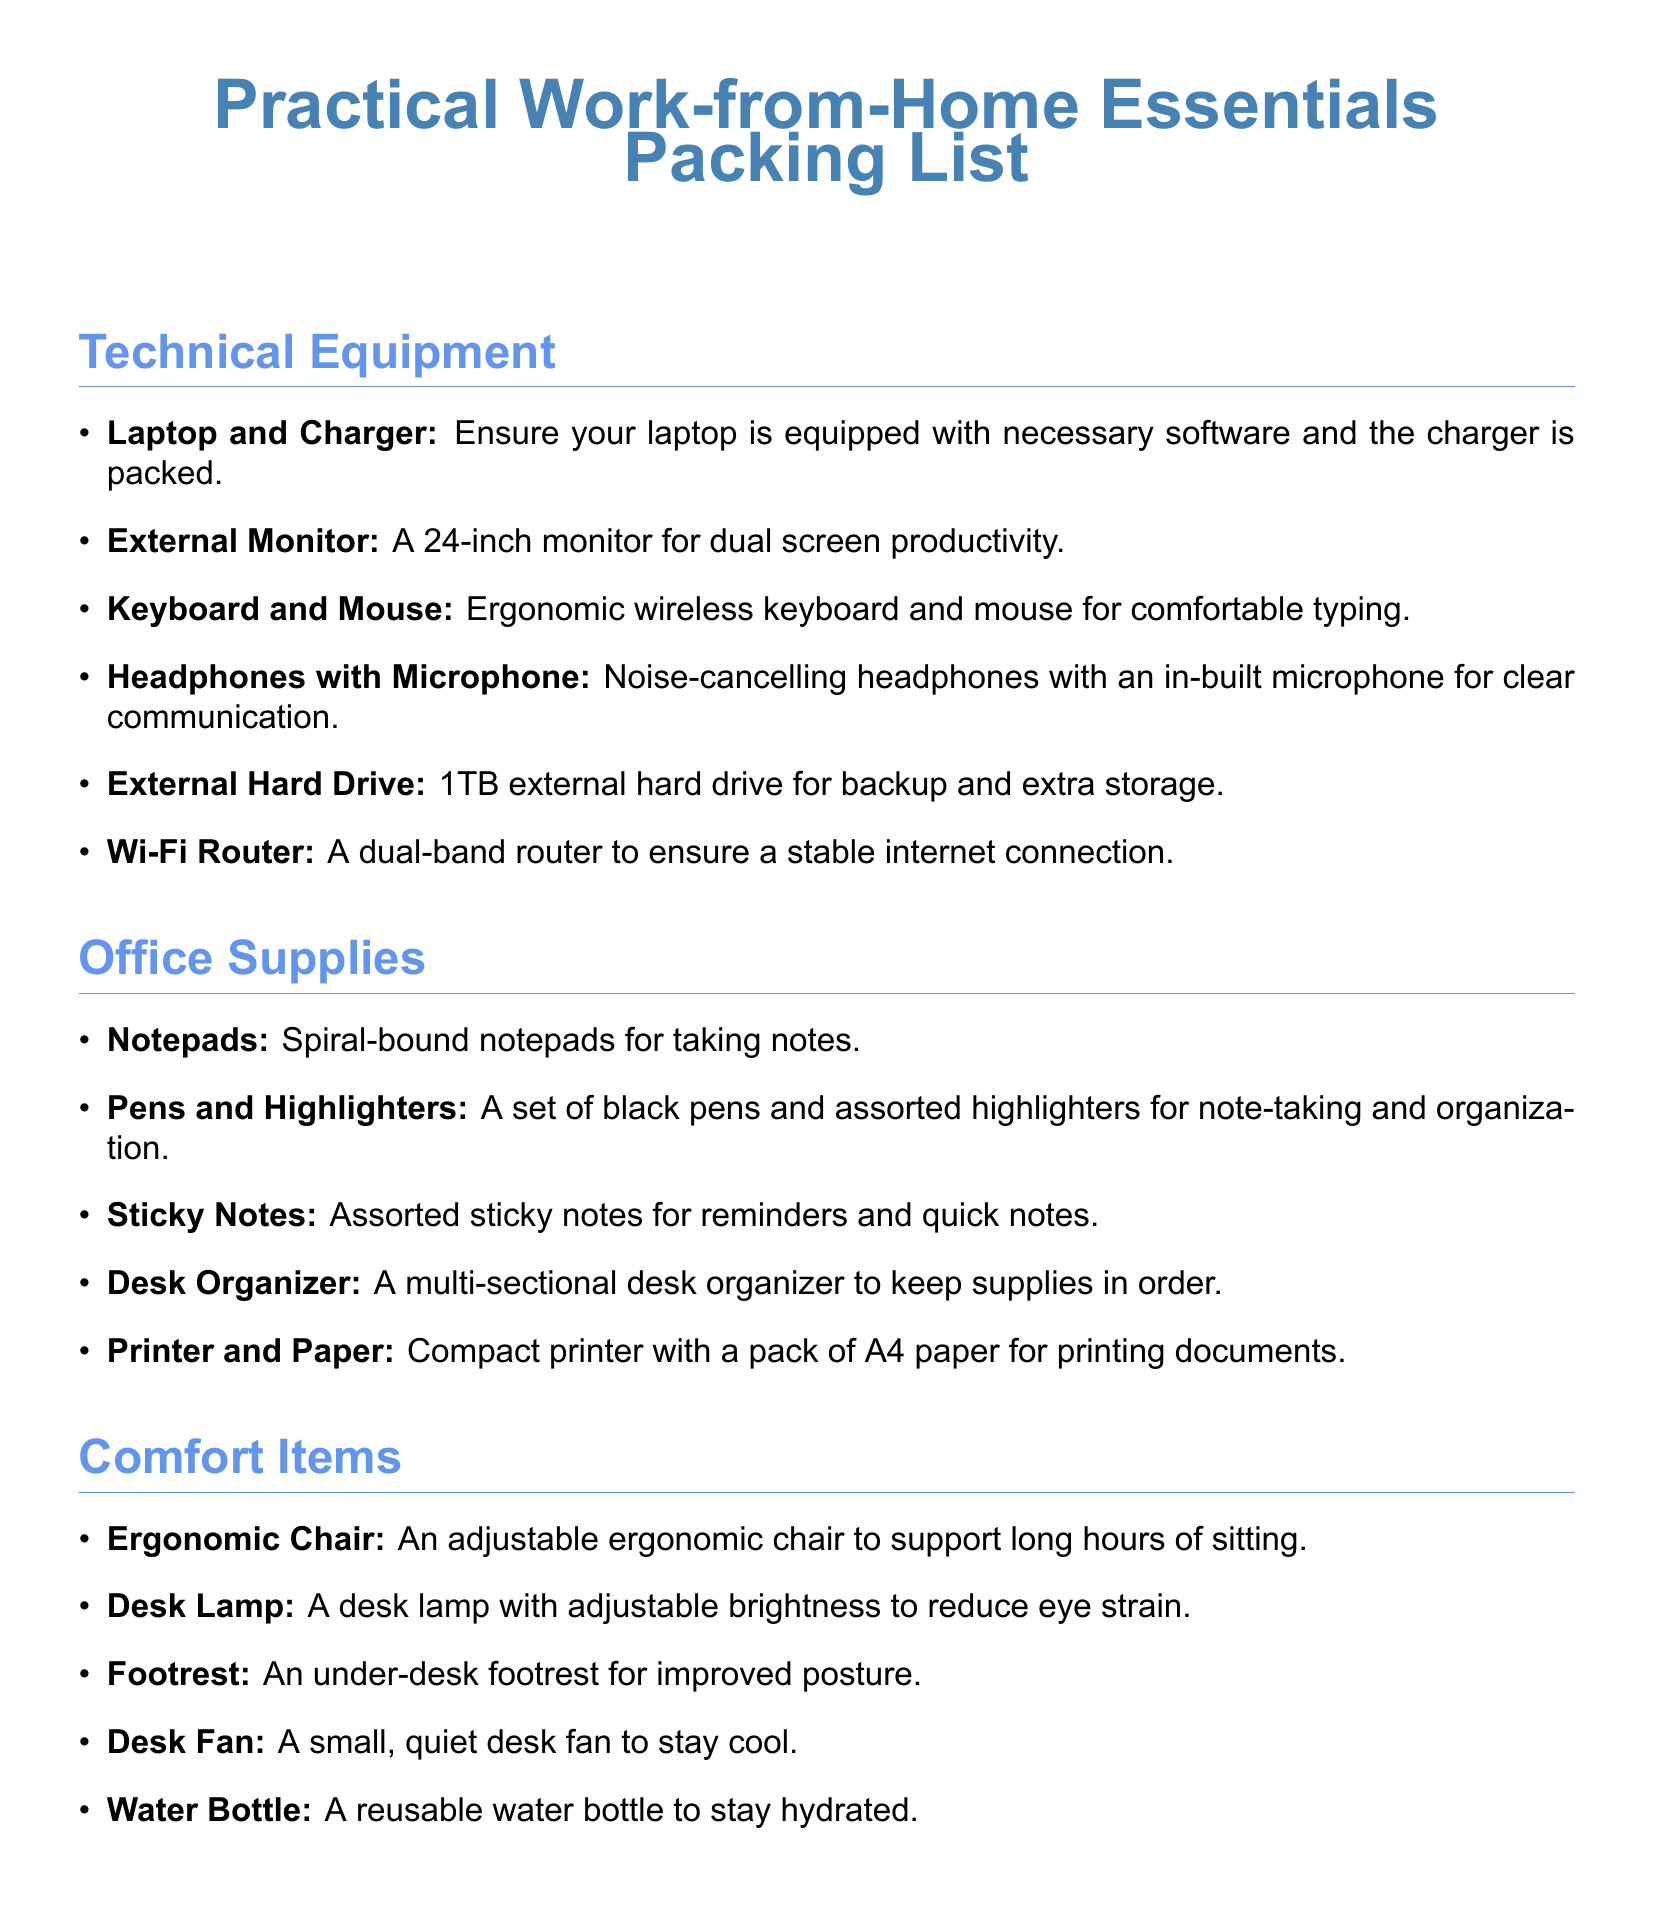what is the first item listed under Technical Equipment? The first item in the Technical Equipment section is the Laptop and Charger.
Answer: Laptop and Charger how many items are listed under Office Supplies? The Office Supplies section contains five items.
Answer: 5 what type of chair is recommended? The document suggests using an ergonomic chair for comfort.
Answer: Ergonomic Chair which item is suggested for note-taking? The item listed for note-taking in the Office Supplies section is Notepads.
Answer: Notepads how many comfort items are mentioned? There are five comfort items listed in the Comfort Items section.
Answer: 5 what is the purpose of the Desk Organizer? The Desk Organizer is meant for keeping supplies in order.
Answer: Keeping supplies in order what is the storage capacity of the External Hard Drive? The External Hard Drive mentioned has a capacity of 1TB.
Answer: 1TB what equipment is required for a stable internet connection? A Wi-Fi Router is recommended for a stable internet connection.
Answer: Wi-Fi Router what does the Desk Lamp help to reduce? The Desk Lamp aids in reducing eye strain.
Answer: Eye strain 